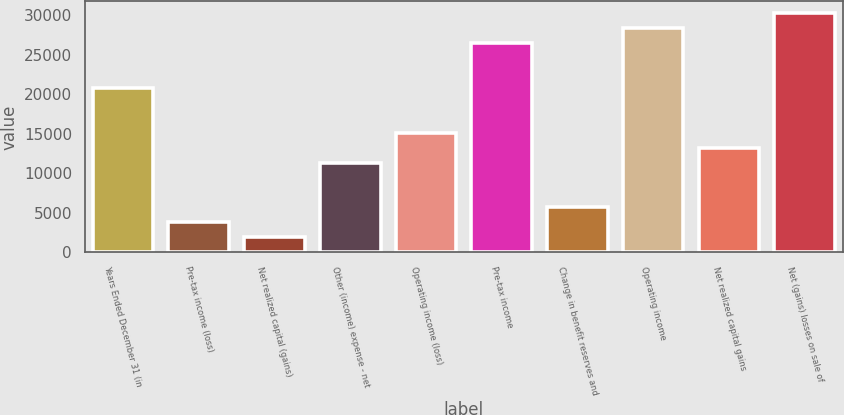Convert chart to OTSL. <chart><loc_0><loc_0><loc_500><loc_500><bar_chart><fcel>Years Ended December 31 (in<fcel>Pre-tax income (loss)<fcel>Net realized capital (gains)<fcel>Other (income) expense - net<fcel>Operating income (loss)<fcel>Pre-tax income<fcel>Change in benefit reserves and<fcel>Operating income<fcel>Net realized capital gains<fcel>Net (gains) losses on sale of<nl><fcel>20786.4<fcel>3781.8<fcel>1892.4<fcel>11339.4<fcel>15118.2<fcel>26454.6<fcel>5671.2<fcel>28344<fcel>13228.8<fcel>30233.4<nl></chart> 